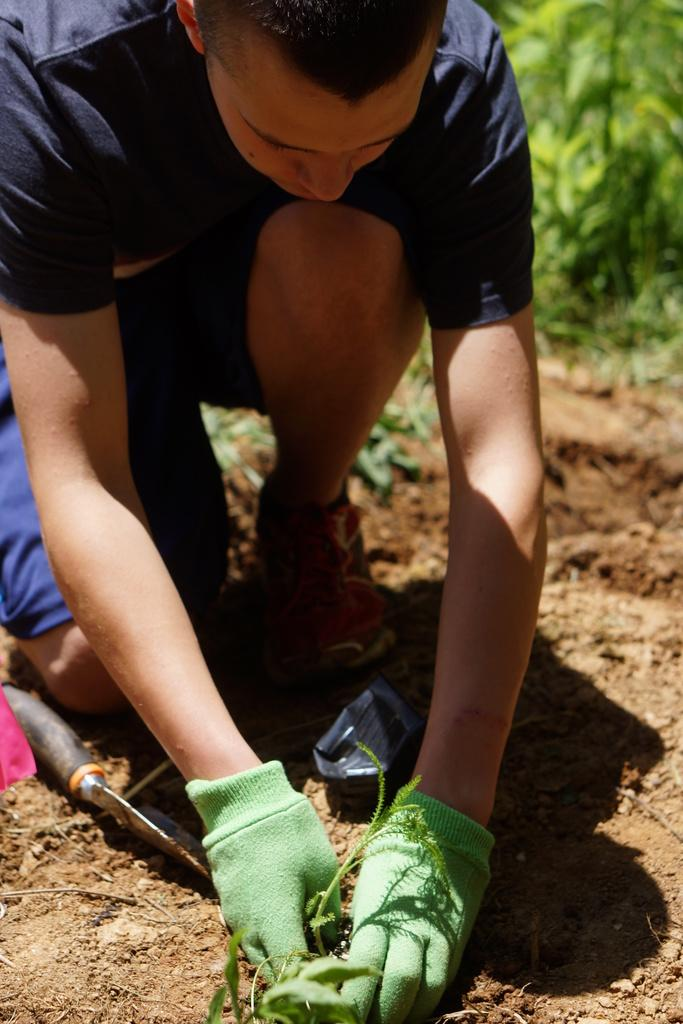Who is in the image? There is a man in the image. What is the man doing in the image? The man is planting in the soil. What can be seen in the man's hand in the image? There is a tool visible in the image. What type of vegetation can be seen in the background of the image? There are green leaves in the background of the image. What type of rhythm is the woman dancing to in the image? There is no woman present in the image, and therefore no dancing or rhythm can be observed. 